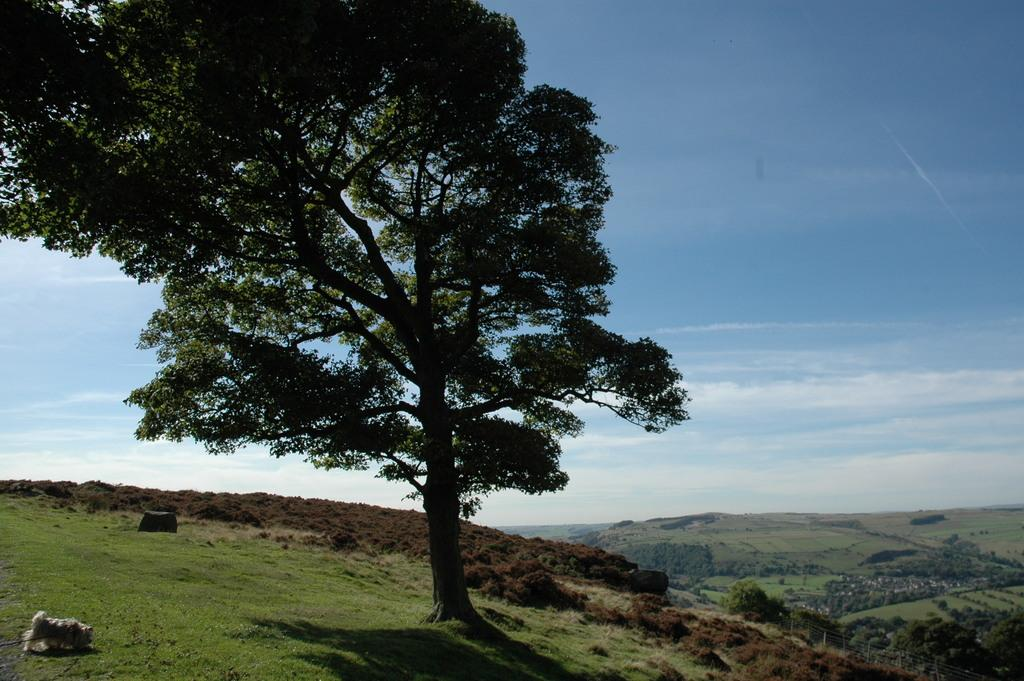What type of terrain is visible in the image? There is a grassy land in the image. What other natural elements can be seen in the image? Trees are present at the bottom of the image. What is visible in the background of the image? The sky is visible in the background of the image. Where is the dog located in the image? The dog is in the bottom left corner of the image. What type of toys can be seen floating in the water near the dock in the image? There is no dock or water present in the image, and therefore no toys can be seen floating. 